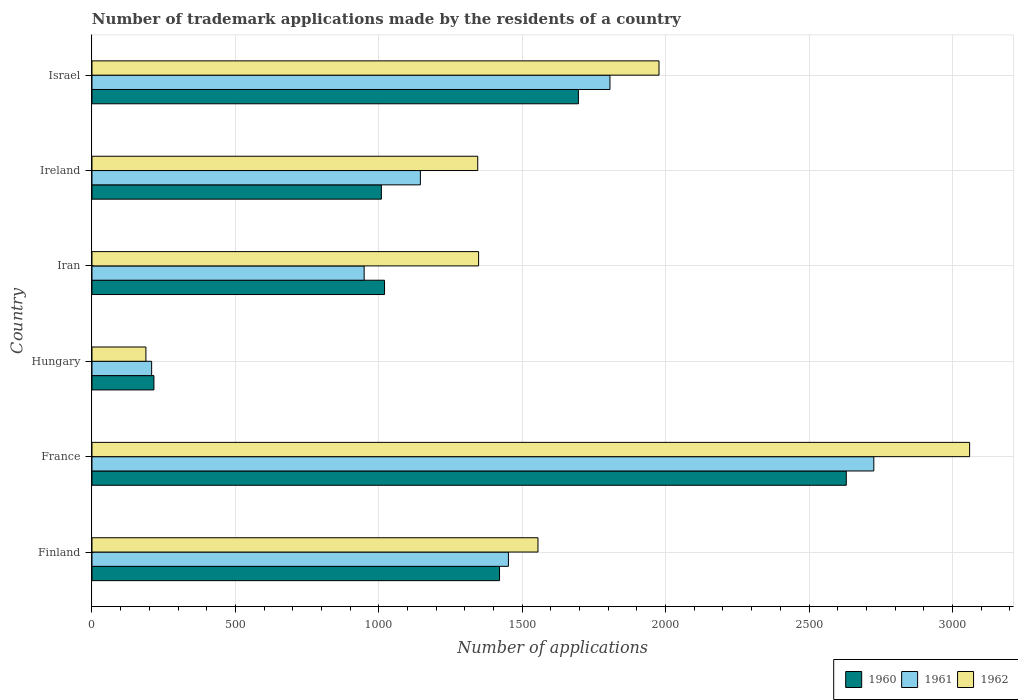How many different coloured bars are there?
Offer a terse response. 3. Are the number of bars per tick equal to the number of legend labels?
Your answer should be very brief. Yes. Are the number of bars on each tick of the Y-axis equal?
Your answer should be compact. Yes. How many bars are there on the 4th tick from the top?
Offer a terse response. 3. How many bars are there on the 6th tick from the bottom?
Make the answer very short. 3. What is the label of the 2nd group of bars from the top?
Give a very brief answer. Ireland. In how many cases, is the number of bars for a given country not equal to the number of legend labels?
Provide a short and direct response. 0. What is the number of trademark applications made by the residents in 1962 in Iran?
Keep it short and to the point. 1348. Across all countries, what is the maximum number of trademark applications made by the residents in 1960?
Provide a short and direct response. 2630. Across all countries, what is the minimum number of trademark applications made by the residents in 1961?
Provide a succinct answer. 208. In which country was the number of trademark applications made by the residents in 1960 minimum?
Offer a very short reply. Hungary. What is the total number of trademark applications made by the residents in 1961 in the graph?
Offer a terse response. 8286. What is the difference between the number of trademark applications made by the residents in 1960 in Hungary and that in Israel?
Give a very brief answer. -1480. What is the difference between the number of trademark applications made by the residents in 1961 in Israel and the number of trademark applications made by the residents in 1962 in Ireland?
Ensure brevity in your answer.  461. What is the average number of trademark applications made by the residents in 1961 per country?
Offer a terse response. 1381. What is the difference between the number of trademark applications made by the residents in 1962 and number of trademark applications made by the residents in 1961 in France?
Offer a terse response. 334. What is the ratio of the number of trademark applications made by the residents in 1961 in Finland to that in Hungary?
Keep it short and to the point. 6.98. Is the number of trademark applications made by the residents in 1960 in France less than that in Ireland?
Your answer should be very brief. No. What is the difference between the highest and the second highest number of trademark applications made by the residents in 1961?
Give a very brief answer. 920. What is the difference between the highest and the lowest number of trademark applications made by the residents in 1960?
Your answer should be very brief. 2414. Is the sum of the number of trademark applications made by the residents in 1960 in France and Hungary greater than the maximum number of trademark applications made by the residents in 1962 across all countries?
Offer a terse response. No. What does the 2nd bar from the top in France represents?
Provide a succinct answer. 1961. How many countries are there in the graph?
Your answer should be very brief. 6. Are the values on the major ticks of X-axis written in scientific E-notation?
Ensure brevity in your answer.  No. Does the graph contain any zero values?
Ensure brevity in your answer.  No. Does the graph contain grids?
Offer a very short reply. Yes. What is the title of the graph?
Offer a terse response. Number of trademark applications made by the residents of a country. What is the label or title of the X-axis?
Make the answer very short. Number of applications. What is the label or title of the Y-axis?
Keep it short and to the point. Country. What is the Number of applications of 1960 in Finland?
Offer a terse response. 1421. What is the Number of applications of 1961 in Finland?
Your answer should be very brief. 1452. What is the Number of applications of 1962 in Finland?
Ensure brevity in your answer.  1555. What is the Number of applications in 1960 in France?
Keep it short and to the point. 2630. What is the Number of applications in 1961 in France?
Provide a succinct answer. 2726. What is the Number of applications in 1962 in France?
Give a very brief answer. 3060. What is the Number of applications of 1960 in Hungary?
Offer a very short reply. 216. What is the Number of applications in 1961 in Hungary?
Keep it short and to the point. 208. What is the Number of applications in 1962 in Hungary?
Ensure brevity in your answer.  188. What is the Number of applications in 1960 in Iran?
Give a very brief answer. 1020. What is the Number of applications of 1961 in Iran?
Your answer should be compact. 949. What is the Number of applications in 1962 in Iran?
Provide a succinct answer. 1348. What is the Number of applications of 1960 in Ireland?
Provide a short and direct response. 1009. What is the Number of applications in 1961 in Ireland?
Keep it short and to the point. 1145. What is the Number of applications of 1962 in Ireland?
Keep it short and to the point. 1345. What is the Number of applications of 1960 in Israel?
Offer a terse response. 1696. What is the Number of applications in 1961 in Israel?
Keep it short and to the point. 1806. What is the Number of applications of 1962 in Israel?
Your response must be concise. 1977. Across all countries, what is the maximum Number of applications in 1960?
Offer a terse response. 2630. Across all countries, what is the maximum Number of applications in 1961?
Ensure brevity in your answer.  2726. Across all countries, what is the maximum Number of applications in 1962?
Provide a succinct answer. 3060. Across all countries, what is the minimum Number of applications of 1960?
Your answer should be compact. 216. Across all countries, what is the minimum Number of applications in 1961?
Your answer should be compact. 208. Across all countries, what is the minimum Number of applications in 1962?
Offer a very short reply. 188. What is the total Number of applications in 1960 in the graph?
Give a very brief answer. 7992. What is the total Number of applications of 1961 in the graph?
Give a very brief answer. 8286. What is the total Number of applications of 1962 in the graph?
Ensure brevity in your answer.  9473. What is the difference between the Number of applications of 1960 in Finland and that in France?
Keep it short and to the point. -1209. What is the difference between the Number of applications in 1961 in Finland and that in France?
Offer a very short reply. -1274. What is the difference between the Number of applications in 1962 in Finland and that in France?
Provide a succinct answer. -1505. What is the difference between the Number of applications of 1960 in Finland and that in Hungary?
Offer a very short reply. 1205. What is the difference between the Number of applications of 1961 in Finland and that in Hungary?
Provide a succinct answer. 1244. What is the difference between the Number of applications in 1962 in Finland and that in Hungary?
Give a very brief answer. 1367. What is the difference between the Number of applications of 1960 in Finland and that in Iran?
Provide a succinct answer. 401. What is the difference between the Number of applications in 1961 in Finland and that in Iran?
Your answer should be very brief. 503. What is the difference between the Number of applications of 1962 in Finland and that in Iran?
Your response must be concise. 207. What is the difference between the Number of applications in 1960 in Finland and that in Ireland?
Keep it short and to the point. 412. What is the difference between the Number of applications of 1961 in Finland and that in Ireland?
Ensure brevity in your answer.  307. What is the difference between the Number of applications of 1962 in Finland and that in Ireland?
Offer a very short reply. 210. What is the difference between the Number of applications in 1960 in Finland and that in Israel?
Offer a very short reply. -275. What is the difference between the Number of applications of 1961 in Finland and that in Israel?
Provide a short and direct response. -354. What is the difference between the Number of applications in 1962 in Finland and that in Israel?
Offer a terse response. -422. What is the difference between the Number of applications of 1960 in France and that in Hungary?
Give a very brief answer. 2414. What is the difference between the Number of applications in 1961 in France and that in Hungary?
Your answer should be compact. 2518. What is the difference between the Number of applications in 1962 in France and that in Hungary?
Provide a short and direct response. 2872. What is the difference between the Number of applications of 1960 in France and that in Iran?
Ensure brevity in your answer.  1610. What is the difference between the Number of applications in 1961 in France and that in Iran?
Keep it short and to the point. 1777. What is the difference between the Number of applications in 1962 in France and that in Iran?
Provide a succinct answer. 1712. What is the difference between the Number of applications in 1960 in France and that in Ireland?
Provide a succinct answer. 1621. What is the difference between the Number of applications in 1961 in France and that in Ireland?
Your response must be concise. 1581. What is the difference between the Number of applications of 1962 in France and that in Ireland?
Ensure brevity in your answer.  1715. What is the difference between the Number of applications of 1960 in France and that in Israel?
Make the answer very short. 934. What is the difference between the Number of applications in 1961 in France and that in Israel?
Offer a very short reply. 920. What is the difference between the Number of applications of 1962 in France and that in Israel?
Provide a short and direct response. 1083. What is the difference between the Number of applications of 1960 in Hungary and that in Iran?
Give a very brief answer. -804. What is the difference between the Number of applications of 1961 in Hungary and that in Iran?
Provide a short and direct response. -741. What is the difference between the Number of applications of 1962 in Hungary and that in Iran?
Provide a short and direct response. -1160. What is the difference between the Number of applications of 1960 in Hungary and that in Ireland?
Give a very brief answer. -793. What is the difference between the Number of applications of 1961 in Hungary and that in Ireland?
Make the answer very short. -937. What is the difference between the Number of applications of 1962 in Hungary and that in Ireland?
Provide a short and direct response. -1157. What is the difference between the Number of applications in 1960 in Hungary and that in Israel?
Give a very brief answer. -1480. What is the difference between the Number of applications in 1961 in Hungary and that in Israel?
Offer a very short reply. -1598. What is the difference between the Number of applications in 1962 in Hungary and that in Israel?
Your answer should be very brief. -1789. What is the difference between the Number of applications of 1960 in Iran and that in Ireland?
Give a very brief answer. 11. What is the difference between the Number of applications in 1961 in Iran and that in Ireland?
Your answer should be compact. -196. What is the difference between the Number of applications of 1962 in Iran and that in Ireland?
Offer a very short reply. 3. What is the difference between the Number of applications in 1960 in Iran and that in Israel?
Offer a terse response. -676. What is the difference between the Number of applications in 1961 in Iran and that in Israel?
Make the answer very short. -857. What is the difference between the Number of applications in 1962 in Iran and that in Israel?
Offer a terse response. -629. What is the difference between the Number of applications in 1960 in Ireland and that in Israel?
Provide a succinct answer. -687. What is the difference between the Number of applications in 1961 in Ireland and that in Israel?
Offer a very short reply. -661. What is the difference between the Number of applications of 1962 in Ireland and that in Israel?
Provide a short and direct response. -632. What is the difference between the Number of applications of 1960 in Finland and the Number of applications of 1961 in France?
Provide a short and direct response. -1305. What is the difference between the Number of applications of 1960 in Finland and the Number of applications of 1962 in France?
Your response must be concise. -1639. What is the difference between the Number of applications in 1961 in Finland and the Number of applications in 1962 in France?
Offer a terse response. -1608. What is the difference between the Number of applications of 1960 in Finland and the Number of applications of 1961 in Hungary?
Offer a very short reply. 1213. What is the difference between the Number of applications of 1960 in Finland and the Number of applications of 1962 in Hungary?
Keep it short and to the point. 1233. What is the difference between the Number of applications of 1961 in Finland and the Number of applications of 1962 in Hungary?
Offer a terse response. 1264. What is the difference between the Number of applications of 1960 in Finland and the Number of applications of 1961 in Iran?
Provide a short and direct response. 472. What is the difference between the Number of applications of 1961 in Finland and the Number of applications of 1962 in Iran?
Ensure brevity in your answer.  104. What is the difference between the Number of applications in 1960 in Finland and the Number of applications in 1961 in Ireland?
Offer a very short reply. 276. What is the difference between the Number of applications of 1961 in Finland and the Number of applications of 1962 in Ireland?
Your response must be concise. 107. What is the difference between the Number of applications in 1960 in Finland and the Number of applications in 1961 in Israel?
Provide a succinct answer. -385. What is the difference between the Number of applications in 1960 in Finland and the Number of applications in 1962 in Israel?
Provide a short and direct response. -556. What is the difference between the Number of applications of 1961 in Finland and the Number of applications of 1962 in Israel?
Your response must be concise. -525. What is the difference between the Number of applications of 1960 in France and the Number of applications of 1961 in Hungary?
Offer a very short reply. 2422. What is the difference between the Number of applications of 1960 in France and the Number of applications of 1962 in Hungary?
Your answer should be compact. 2442. What is the difference between the Number of applications in 1961 in France and the Number of applications in 1962 in Hungary?
Provide a succinct answer. 2538. What is the difference between the Number of applications in 1960 in France and the Number of applications in 1961 in Iran?
Your answer should be compact. 1681. What is the difference between the Number of applications in 1960 in France and the Number of applications in 1962 in Iran?
Provide a short and direct response. 1282. What is the difference between the Number of applications in 1961 in France and the Number of applications in 1962 in Iran?
Your response must be concise. 1378. What is the difference between the Number of applications in 1960 in France and the Number of applications in 1961 in Ireland?
Offer a terse response. 1485. What is the difference between the Number of applications in 1960 in France and the Number of applications in 1962 in Ireland?
Keep it short and to the point. 1285. What is the difference between the Number of applications in 1961 in France and the Number of applications in 1962 in Ireland?
Ensure brevity in your answer.  1381. What is the difference between the Number of applications in 1960 in France and the Number of applications in 1961 in Israel?
Ensure brevity in your answer.  824. What is the difference between the Number of applications in 1960 in France and the Number of applications in 1962 in Israel?
Provide a succinct answer. 653. What is the difference between the Number of applications of 1961 in France and the Number of applications of 1962 in Israel?
Your response must be concise. 749. What is the difference between the Number of applications of 1960 in Hungary and the Number of applications of 1961 in Iran?
Your answer should be compact. -733. What is the difference between the Number of applications of 1960 in Hungary and the Number of applications of 1962 in Iran?
Your answer should be very brief. -1132. What is the difference between the Number of applications of 1961 in Hungary and the Number of applications of 1962 in Iran?
Offer a very short reply. -1140. What is the difference between the Number of applications in 1960 in Hungary and the Number of applications in 1961 in Ireland?
Offer a very short reply. -929. What is the difference between the Number of applications in 1960 in Hungary and the Number of applications in 1962 in Ireland?
Your response must be concise. -1129. What is the difference between the Number of applications in 1961 in Hungary and the Number of applications in 1962 in Ireland?
Provide a succinct answer. -1137. What is the difference between the Number of applications of 1960 in Hungary and the Number of applications of 1961 in Israel?
Offer a terse response. -1590. What is the difference between the Number of applications in 1960 in Hungary and the Number of applications in 1962 in Israel?
Offer a very short reply. -1761. What is the difference between the Number of applications in 1961 in Hungary and the Number of applications in 1962 in Israel?
Offer a terse response. -1769. What is the difference between the Number of applications of 1960 in Iran and the Number of applications of 1961 in Ireland?
Ensure brevity in your answer.  -125. What is the difference between the Number of applications of 1960 in Iran and the Number of applications of 1962 in Ireland?
Provide a succinct answer. -325. What is the difference between the Number of applications of 1961 in Iran and the Number of applications of 1962 in Ireland?
Offer a very short reply. -396. What is the difference between the Number of applications of 1960 in Iran and the Number of applications of 1961 in Israel?
Offer a very short reply. -786. What is the difference between the Number of applications in 1960 in Iran and the Number of applications in 1962 in Israel?
Provide a short and direct response. -957. What is the difference between the Number of applications in 1961 in Iran and the Number of applications in 1962 in Israel?
Provide a succinct answer. -1028. What is the difference between the Number of applications in 1960 in Ireland and the Number of applications in 1961 in Israel?
Provide a short and direct response. -797. What is the difference between the Number of applications of 1960 in Ireland and the Number of applications of 1962 in Israel?
Make the answer very short. -968. What is the difference between the Number of applications of 1961 in Ireland and the Number of applications of 1962 in Israel?
Provide a short and direct response. -832. What is the average Number of applications in 1960 per country?
Your answer should be very brief. 1332. What is the average Number of applications of 1961 per country?
Your response must be concise. 1381. What is the average Number of applications of 1962 per country?
Provide a short and direct response. 1578.83. What is the difference between the Number of applications of 1960 and Number of applications of 1961 in Finland?
Give a very brief answer. -31. What is the difference between the Number of applications in 1960 and Number of applications in 1962 in Finland?
Offer a terse response. -134. What is the difference between the Number of applications of 1961 and Number of applications of 1962 in Finland?
Provide a succinct answer. -103. What is the difference between the Number of applications in 1960 and Number of applications in 1961 in France?
Your response must be concise. -96. What is the difference between the Number of applications of 1960 and Number of applications of 1962 in France?
Offer a very short reply. -430. What is the difference between the Number of applications of 1961 and Number of applications of 1962 in France?
Provide a short and direct response. -334. What is the difference between the Number of applications in 1960 and Number of applications in 1961 in Hungary?
Provide a succinct answer. 8. What is the difference between the Number of applications in 1960 and Number of applications in 1962 in Hungary?
Provide a short and direct response. 28. What is the difference between the Number of applications of 1960 and Number of applications of 1962 in Iran?
Offer a terse response. -328. What is the difference between the Number of applications in 1961 and Number of applications in 1962 in Iran?
Provide a succinct answer. -399. What is the difference between the Number of applications of 1960 and Number of applications of 1961 in Ireland?
Provide a succinct answer. -136. What is the difference between the Number of applications in 1960 and Number of applications in 1962 in Ireland?
Offer a very short reply. -336. What is the difference between the Number of applications in 1961 and Number of applications in 1962 in Ireland?
Offer a terse response. -200. What is the difference between the Number of applications of 1960 and Number of applications of 1961 in Israel?
Give a very brief answer. -110. What is the difference between the Number of applications in 1960 and Number of applications in 1962 in Israel?
Your answer should be very brief. -281. What is the difference between the Number of applications of 1961 and Number of applications of 1962 in Israel?
Make the answer very short. -171. What is the ratio of the Number of applications in 1960 in Finland to that in France?
Your answer should be compact. 0.54. What is the ratio of the Number of applications in 1961 in Finland to that in France?
Your response must be concise. 0.53. What is the ratio of the Number of applications in 1962 in Finland to that in France?
Offer a very short reply. 0.51. What is the ratio of the Number of applications in 1960 in Finland to that in Hungary?
Your answer should be very brief. 6.58. What is the ratio of the Number of applications of 1961 in Finland to that in Hungary?
Your answer should be very brief. 6.98. What is the ratio of the Number of applications of 1962 in Finland to that in Hungary?
Keep it short and to the point. 8.27. What is the ratio of the Number of applications of 1960 in Finland to that in Iran?
Offer a terse response. 1.39. What is the ratio of the Number of applications in 1961 in Finland to that in Iran?
Make the answer very short. 1.53. What is the ratio of the Number of applications of 1962 in Finland to that in Iran?
Your answer should be compact. 1.15. What is the ratio of the Number of applications in 1960 in Finland to that in Ireland?
Keep it short and to the point. 1.41. What is the ratio of the Number of applications of 1961 in Finland to that in Ireland?
Give a very brief answer. 1.27. What is the ratio of the Number of applications of 1962 in Finland to that in Ireland?
Provide a short and direct response. 1.16. What is the ratio of the Number of applications in 1960 in Finland to that in Israel?
Give a very brief answer. 0.84. What is the ratio of the Number of applications in 1961 in Finland to that in Israel?
Your answer should be compact. 0.8. What is the ratio of the Number of applications of 1962 in Finland to that in Israel?
Provide a succinct answer. 0.79. What is the ratio of the Number of applications of 1960 in France to that in Hungary?
Your answer should be very brief. 12.18. What is the ratio of the Number of applications in 1961 in France to that in Hungary?
Offer a very short reply. 13.11. What is the ratio of the Number of applications in 1962 in France to that in Hungary?
Ensure brevity in your answer.  16.28. What is the ratio of the Number of applications in 1960 in France to that in Iran?
Your answer should be compact. 2.58. What is the ratio of the Number of applications in 1961 in France to that in Iran?
Give a very brief answer. 2.87. What is the ratio of the Number of applications in 1962 in France to that in Iran?
Ensure brevity in your answer.  2.27. What is the ratio of the Number of applications of 1960 in France to that in Ireland?
Your answer should be compact. 2.61. What is the ratio of the Number of applications in 1961 in France to that in Ireland?
Provide a short and direct response. 2.38. What is the ratio of the Number of applications of 1962 in France to that in Ireland?
Offer a terse response. 2.28. What is the ratio of the Number of applications in 1960 in France to that in Israel?
Your answer should be compact. 1.55. What is the ratio of the Number of applications of 1961 in France to that in Israel?
Provide a short and direct response. 1.51. What is the ratio of the Number of applications in 1962 in France to that in Israel?
Keep it short and to the point. 1.55. What is the ratio of the Number of applications in 1960 in Hungary to that in Iran?
Your answer should be very brief. 0.21. What is the ratio of the Number of applications in 1961 in Hungary to that in Iran?
Offer a very short reply. 0.22. What is the ratio of the Number of applications in 1962 in Hungary to that in Iran?
Your response must be concise. 0.14. What is the ratio of the Number of applications of 1960 in Hungary to that in Ireland?
Offer a very short reply. 0.21. What is the ratio of the Number of applications of 1961 in Hungary to that in Ireland?
Make the answer very short. 0.18. What is the ratio of the Number of applications of 1962 in Hungary to that in Ireland?
Offer a terse response. 0.14. What is the ratio of the Number of applications in 1960 in Hungary to that in Israel?
Make the answer very short. 0.13. What is the ratio of the Number of applications in 1961 in Hungary to that in Israel?
Ensure brevity in your answer.  0.12. What is the ratio of the Number of applications in 1962 in Hungary to that in Israel?
Make the answer very short. 0.1. What is the ratio of the Number of applications of 1960 in Iran to that in Ireland?
Keep it short and to the point. 1.01. What is the ratio of the Number of applications in 1961 in Iran to that in Ireland?
Offer a very short reply. 0.83. What is the ratio of the Number of applications of 1960 in Iran to that in Israel?
Your answer should be very brief. 0.6. What is the ratio of the Number of applications in 1961 in Iran to that in Israel?
Your answer should be compact. 0.53. What is the ratio of the Number of applications of 1962 in Iran to that in Israel?
Give a very brief answer. 0.68. What is the ratio of the Number of applications of 1960 in Ireland to that in Israel?
Ensure brevity in your answer.  0.59. What is the ratio of the Number of applications of 1961 in Ireland to that in Israel?
Provide a succinct answer. 0.63. What is the ratio of the Number of applications of 1962 in Ireland to that in Israel?
Keep it short and to the point. 0.68. What is the difference between the highest and the second highest Number of applications in 1960?
Your response must be concise. 934. What is the difference between the highest and the second highest Number of applications of 1961?
Your answer should be compact. 920. What is the difference between the highest and the second highest Number of applications of 1962?
Provide a succinct answer. 1083. What is the difference between the highest and the lowest Number of applications of 1960?
Your answer should be very brief. 2414. What is the difference between the highest and the lowest Number of applications in 1961?
Make the answer very short. 2518. What is the difference between the highest and the lowest Number of applications of 1962?
Make the answer very short. 2872. 